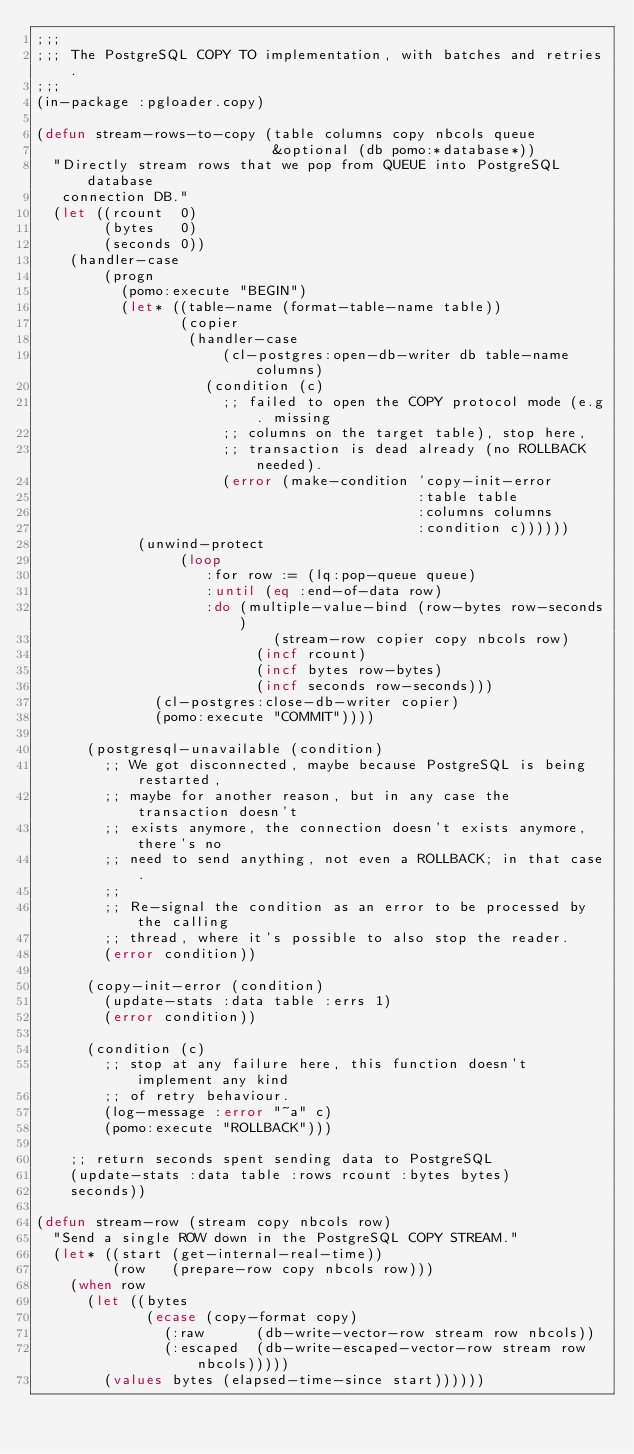Convert code to text. <code><loc_0><loc_0><loc_500><loc_500><_Lisp_>;;;
;;; The PostgreSQL COPY TO implementation, with batches and retries.
;;;
(in-package :pgloader.copy)

(defun stream-rows-to-copy (table columns copy nbcols queue
                            &optional (db pomo:*database*))
  "Directly stream rows that we pop from QUEUE into PostgreSQL database
   connection DB."
  (let ((rcount  0)
        (bytes   0)
        (seconds 0))
    (handler-case
        (progn
          (pomo:execute "BEGIN")
          (let* ((table-name (format-table-name table))
                 (copier
                  (handler-case
                      (cl-postgres:open-db-writer db table-name columns)
                    (condition (c)
                      ;; failed to open the COPY protocol mode (e.g. missing
                      ;; columns on the target table), stop here,
                      ;; transaction is dead already (no ROLLBACK needed).
                      (error (make-condition 'copy-init-error
                                             :table table
                                             :columns columns
                                             :condition c))))))
            (unwind-protect
                 (loop
                    :for row := (lq:pop-queue queue)
                    :until (eq :end-of-data row)
                    :do (multiple-value-bind (row-bytes row-seconds)
                            (stream-row copier copy nbcols row)
                          (incf rcount)
                          (incf bytes row-bytes)
                          (incf seconds row-seconds)))
              (cl-postgres:close-db-writer copier)
              (pomo:execute "COMMIT"))))

      (postgresql-unavailable (condition)
        ;; We got disconnected, maybe because PostgreSQL is being restarted,
        ;; maybe for another reason, but in any case the transaction doesn't
        ;; exists anymore, the connection doesn't exists anymore, there's no
        ;; need to send anything, not even a ROLLBACK; in that case.
        ;;
        ;; Re-signal the condition as an error to be processed by the calling
        ;; thread, where it's possible to also stop the reader.
        (error condition))

      (copy-init-error (condition)
        (update-stats :data table :errs 1)
        (error condition))

      (condition (c)
        ;; stop at any failure here, this function doesn't implement any kind
        ;; of retry behaviour.
        (log-message :error "~a" c)
        (pomo:execute "ROLLBACK")))

    ;; return seconds spent sending data to PostgreSQL
    (update-stats :data table :rows rcount :bytes bytes)
    seconds))

(defun stream-row (stream copy nbcols row)
  "Send a single ROW down in the PostgreSQL COPY STREAM."
  (let* ((start (get-internal-real-time))
         (row   (prepare-row copy nbcols row)))
    (when row
      (let ((bytes
             (ecase (copy-format copy)
               (:raw      (db-write-vector-row stream row nbcols))
               (:escaped  (db-write-escaped-vector-row stream row nbcols)))))
        (values bytes (elapsed-time-since start))))))
</code> 